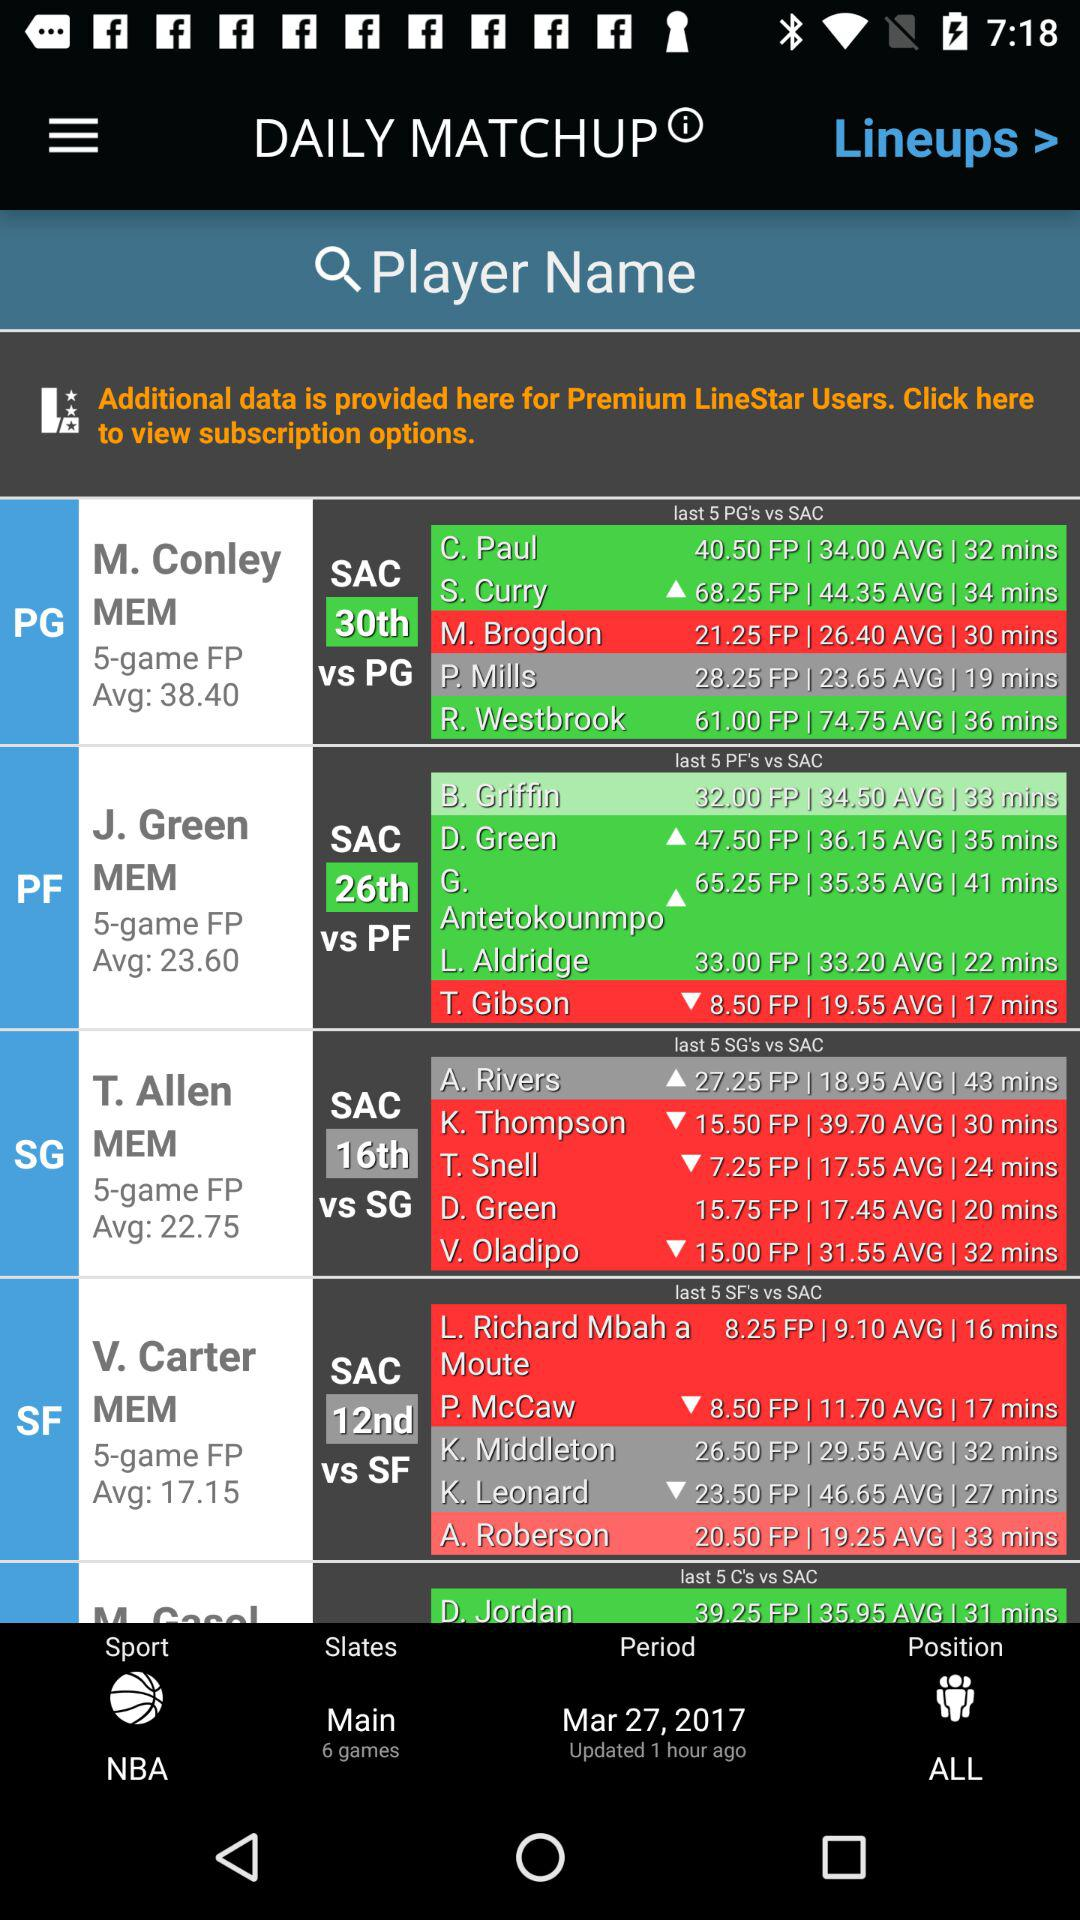What is the date? The date is March 27, 2017. 